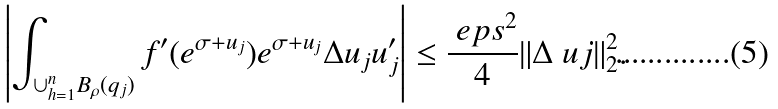<formula> <loc_0><loc_0><loc_500><loc_500>\left | \int _ { \cup _ { h = 1 } ^ { n } B _ { \rho } ( q _ { j } ) } f ^ { \prime } ( e ^ { \sigma + u _ { j } } ) e ^ { \sigma + u _ { j } } \Delta u _ { j } u _ { j } ^ { \prime } \right | \leq \frac { \ e p s ^ { 2 } } { 4 } \| \Delta \ u j \| _ { 2 } ^ { 2 } .</formula> 